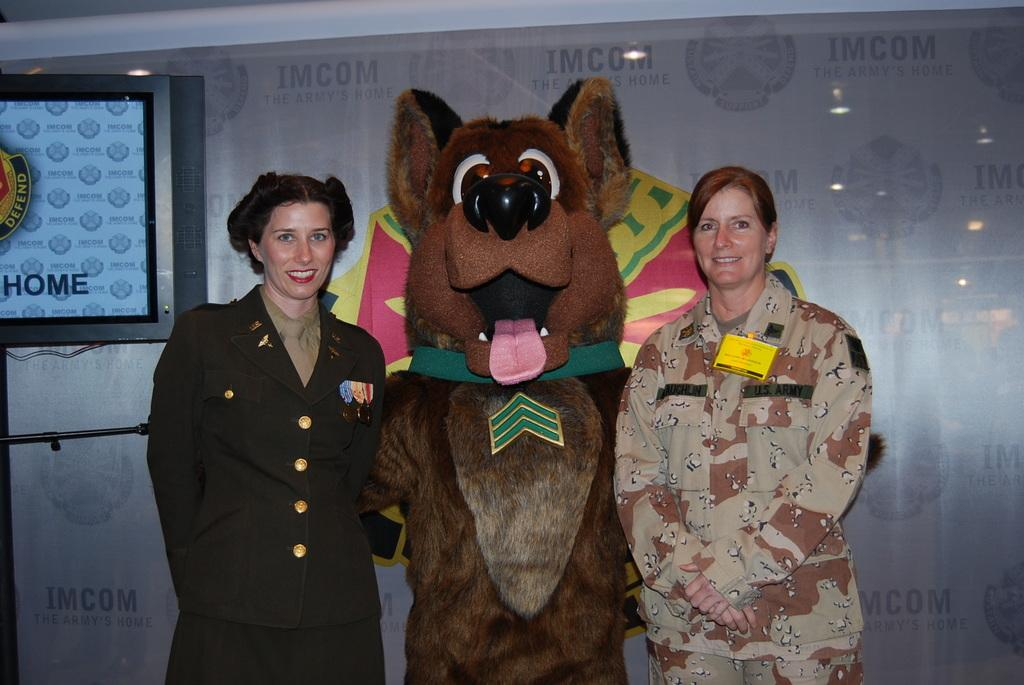What is the main subject in the image? There is a doll in the image. Are there any other subjects in the image besides the doll? Yes, there are persons in the image. What are the persons wearing? The persons are wearing clothes. What can be seen in the top left corner of the image? There is a screen in the top left of the image. What type of ray is visible in the image? There is no ray present in the image. Do the persons in the image believe in the power of the doll? The image does not provide any information about the beliefs of the persons in the image. 